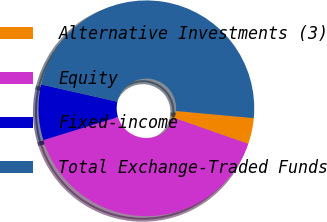Convert chart to OTSL. <chart><loc_0><loc_0><loc_500><loc_500><pie_chart><fcel>Alternative Investments (3)<fcel>Equity<fcel>Fixed-income<fcel>Total Exchange-Traded Funds<nl><fcel>3.91%<fcel>39.88%<fcel>8.31%<fcel>47.9%<nl></chart> 